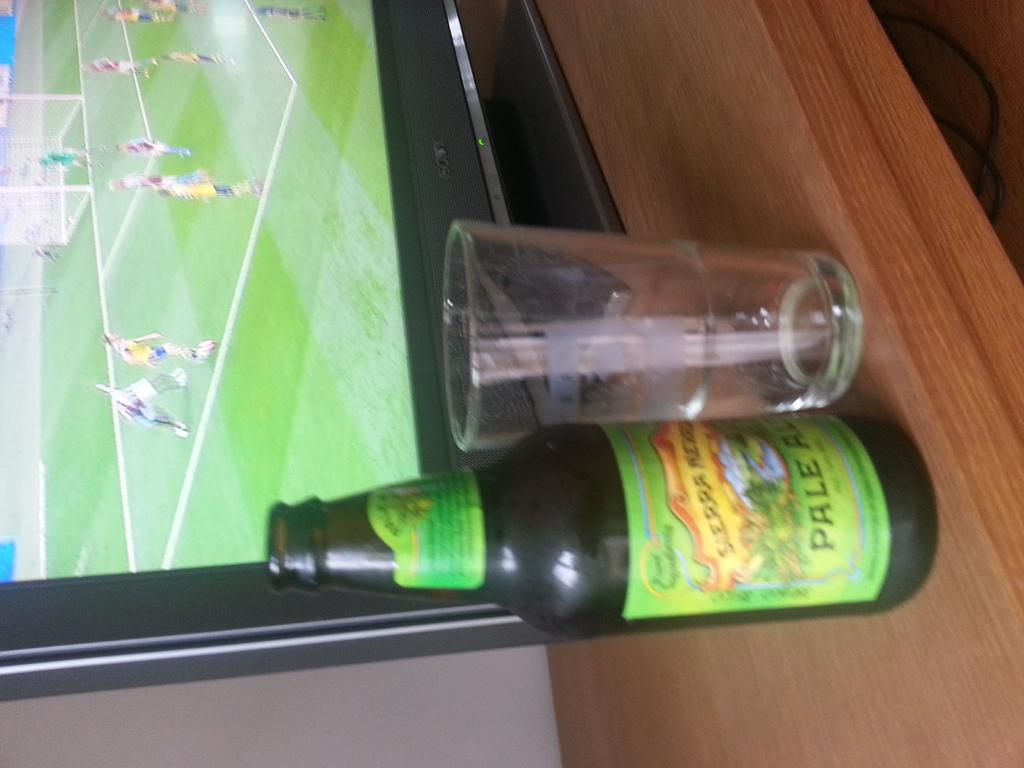<image>
Relay a brief, clear account of the picture shown. A Pale Ale bottle with a green label sits in front of a TV. 